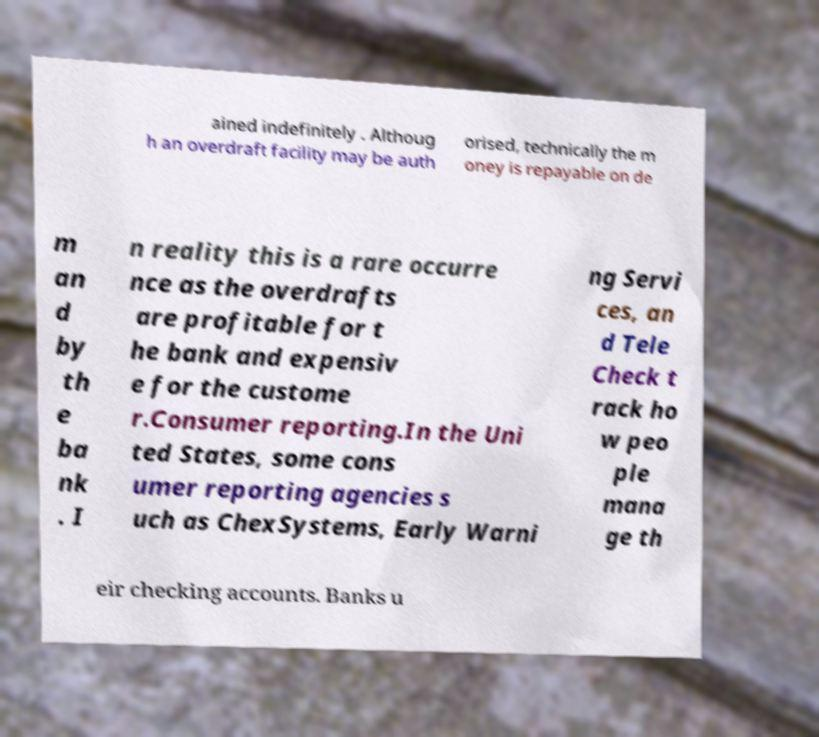Can you accurately transcribe the text from the provided image for me? ained indefinitely . Althoug h an overdraft facility may be auth orised, technically the m oney is repayable on de m an d by th e ba nk . I n reality this is a rare occurre nce as the overdrafts are profitable for t he bank and expensiv e for the custome r.Consumer reporting.In the Uni ted States, some cons umer reporting agencies s uch as ChexSystems, Early Warni ng Servi ces, an d Tele Check t rack ho w peo ple mana ge th eir checking accounts. Banks u 